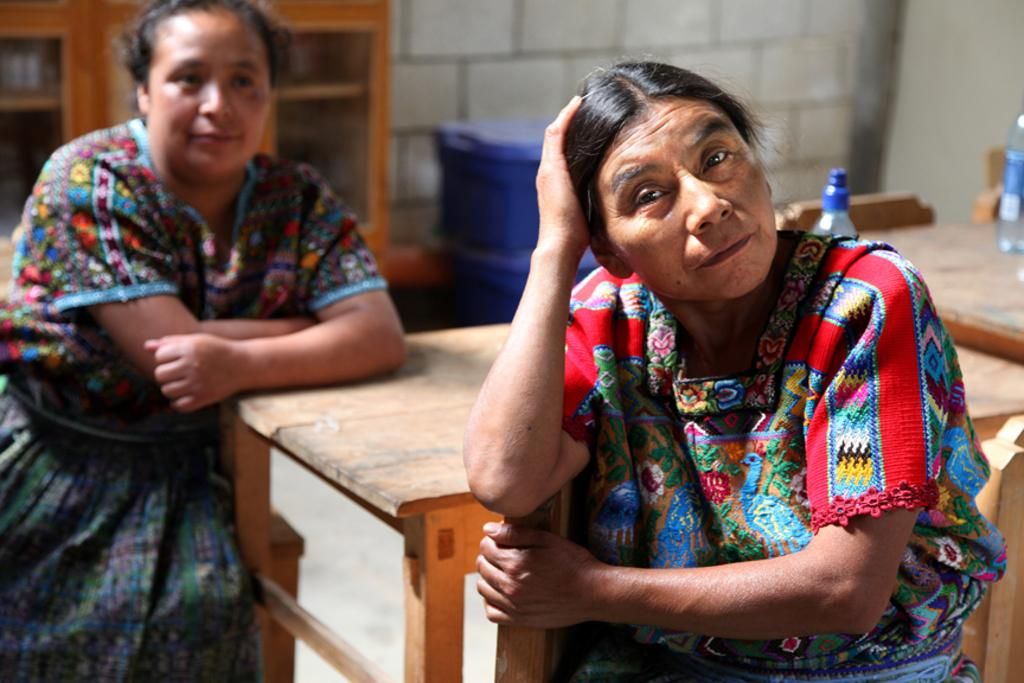How many women are in the image? There are two women in the image. What are the women doing in the image? The women are sitting on chairs. Where are the chairs located in relation to the table? The chairs are around a table. What can be seen on the table? There are two bottles on the table. What is visible in the background of the image? There is a wall, a cupboard, and other objects visible in the background. What type of education can be seen in the image? There is no indication of education in the image; it features two women sitting around a table with bottles. How does the wind affect the scene in the image? There is no mention of wind in the image, and it is not possible to determine its effect on the scene. 